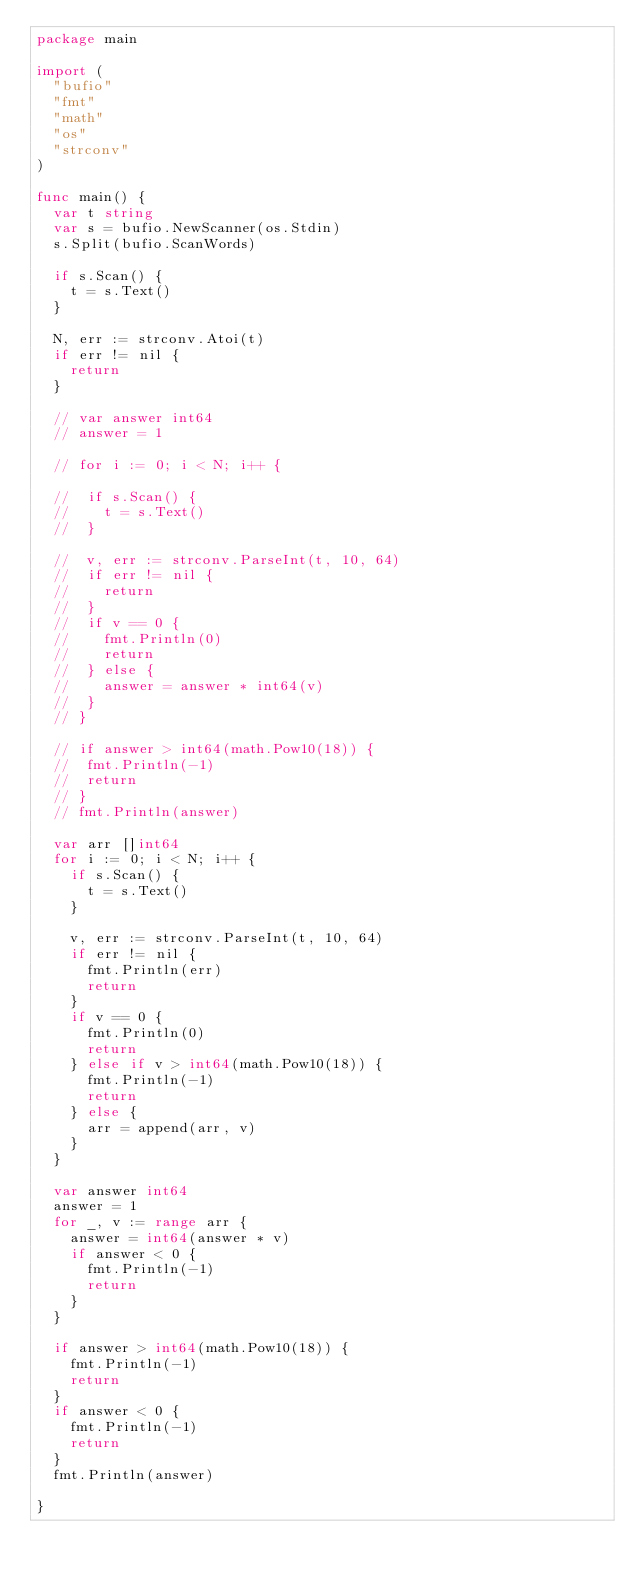<code> <loc_0><loc_0><loc_500><loc_500><_Go_>package main

import (
	"bufio"
	"fmt"
	"math"
	"os"
	"strconv"
)

func main() {
	var t string
	var s = bufio.NewScanner(os.Stdin)
	s.Split(bufio.ScanWords)

	if s.Scan() {
		t = s.Text()
	}

	N, err := strconv.Atoi(t)
	if err != nil {
		return
	}

	// var answer int64
	// answer = 1

	// for i := 0; i < N; i++ {

	// 	if s.Scan() {
	// 		t = s.Text()
	// 	}

	// 	v, err := strconv.ParseInt(t, 10, 64)
	// 	if err != nil {
	// 		return
	// 	}
	// 	if v == 0 {
	// 		fmt.Println(0)
	// 		return
	// 	} else {
	// 		answer = answer * int64(v)
	// 	}
	// }

	// if answer > int64(math.Pow10(18)) {
	// 	fmt.Println(-1)
	// 	return
	// }
	// fmt.Println(answer)

	var arr []int64
	for i := 0; i < N; i++ {
		if s.Scan() {
			t = s.Text()
		}

		v, err := strconv.ParseInt(t, 10, 64)
		if err != nil {
			fmt.Println(err)
			return
		}
		if v == 0 {
			fmt.Println(0)
			return
		} else if v > int64(math.Pow10(18)) {
			fmt.Println(-1)
			return
		} else {
			arr = append(arr, v)
		}
	}

	var answer int64
	answer = 1
	for _, v := range arr {
		answer = int64(answer * v)
		if answer < 0 {
			fmt.Println(-1)
			return
		}
	}

	if answer > int64(math.Pow10(18)) {
		fmt.Println(-1)
		return
	}
	if answer < 0 {
		fmt.Println(-1)
		return
	}
	fmt.Println(answer)

}
</code> 